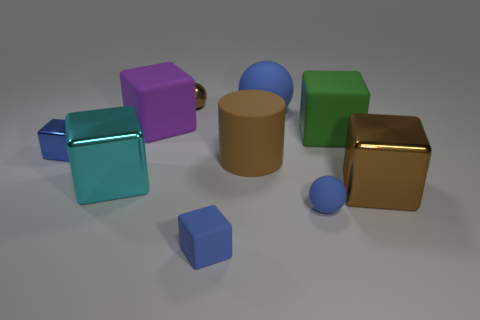Are there any blue matte objects in front of the metal cube that is to the right of the blue object behind the green matte thing?
Your answer should be compact. Yes. Are there any small yellow metallic balls?
Provide a short and direct response. No. Is the number of blue matte things behind the big cyan thing greater than the number of brown spheres to the right of the big green thing?
Offer a very short reply. Yes. There is a purple object that is the same material as the big blue sphere; what is its size?
Your answer should be very brief. Large. There is a brown shiny object that is on the left side of the tiny sphere in front of the big brown thing to the right of the big blue ball; how big is it?
Make the answer very short. Small. What is the color of the thing that is in front of the small blue sphere?
Offer a very short reply. Blue. Are there more tiny cubes in front of the blue metal block than gray matte things?
Offer a very short reply. Yes. There is a brown object behind the big cylinder; is its shape the same as the large blue thing?
Offer a very short reply. Yes. What number of brown objects are metal spheres or cylinders?
Your answer should be very brief. 2. Are there more large blue metallic spheres than brown rubber cylinders?
Provide a short and direct response. No. 